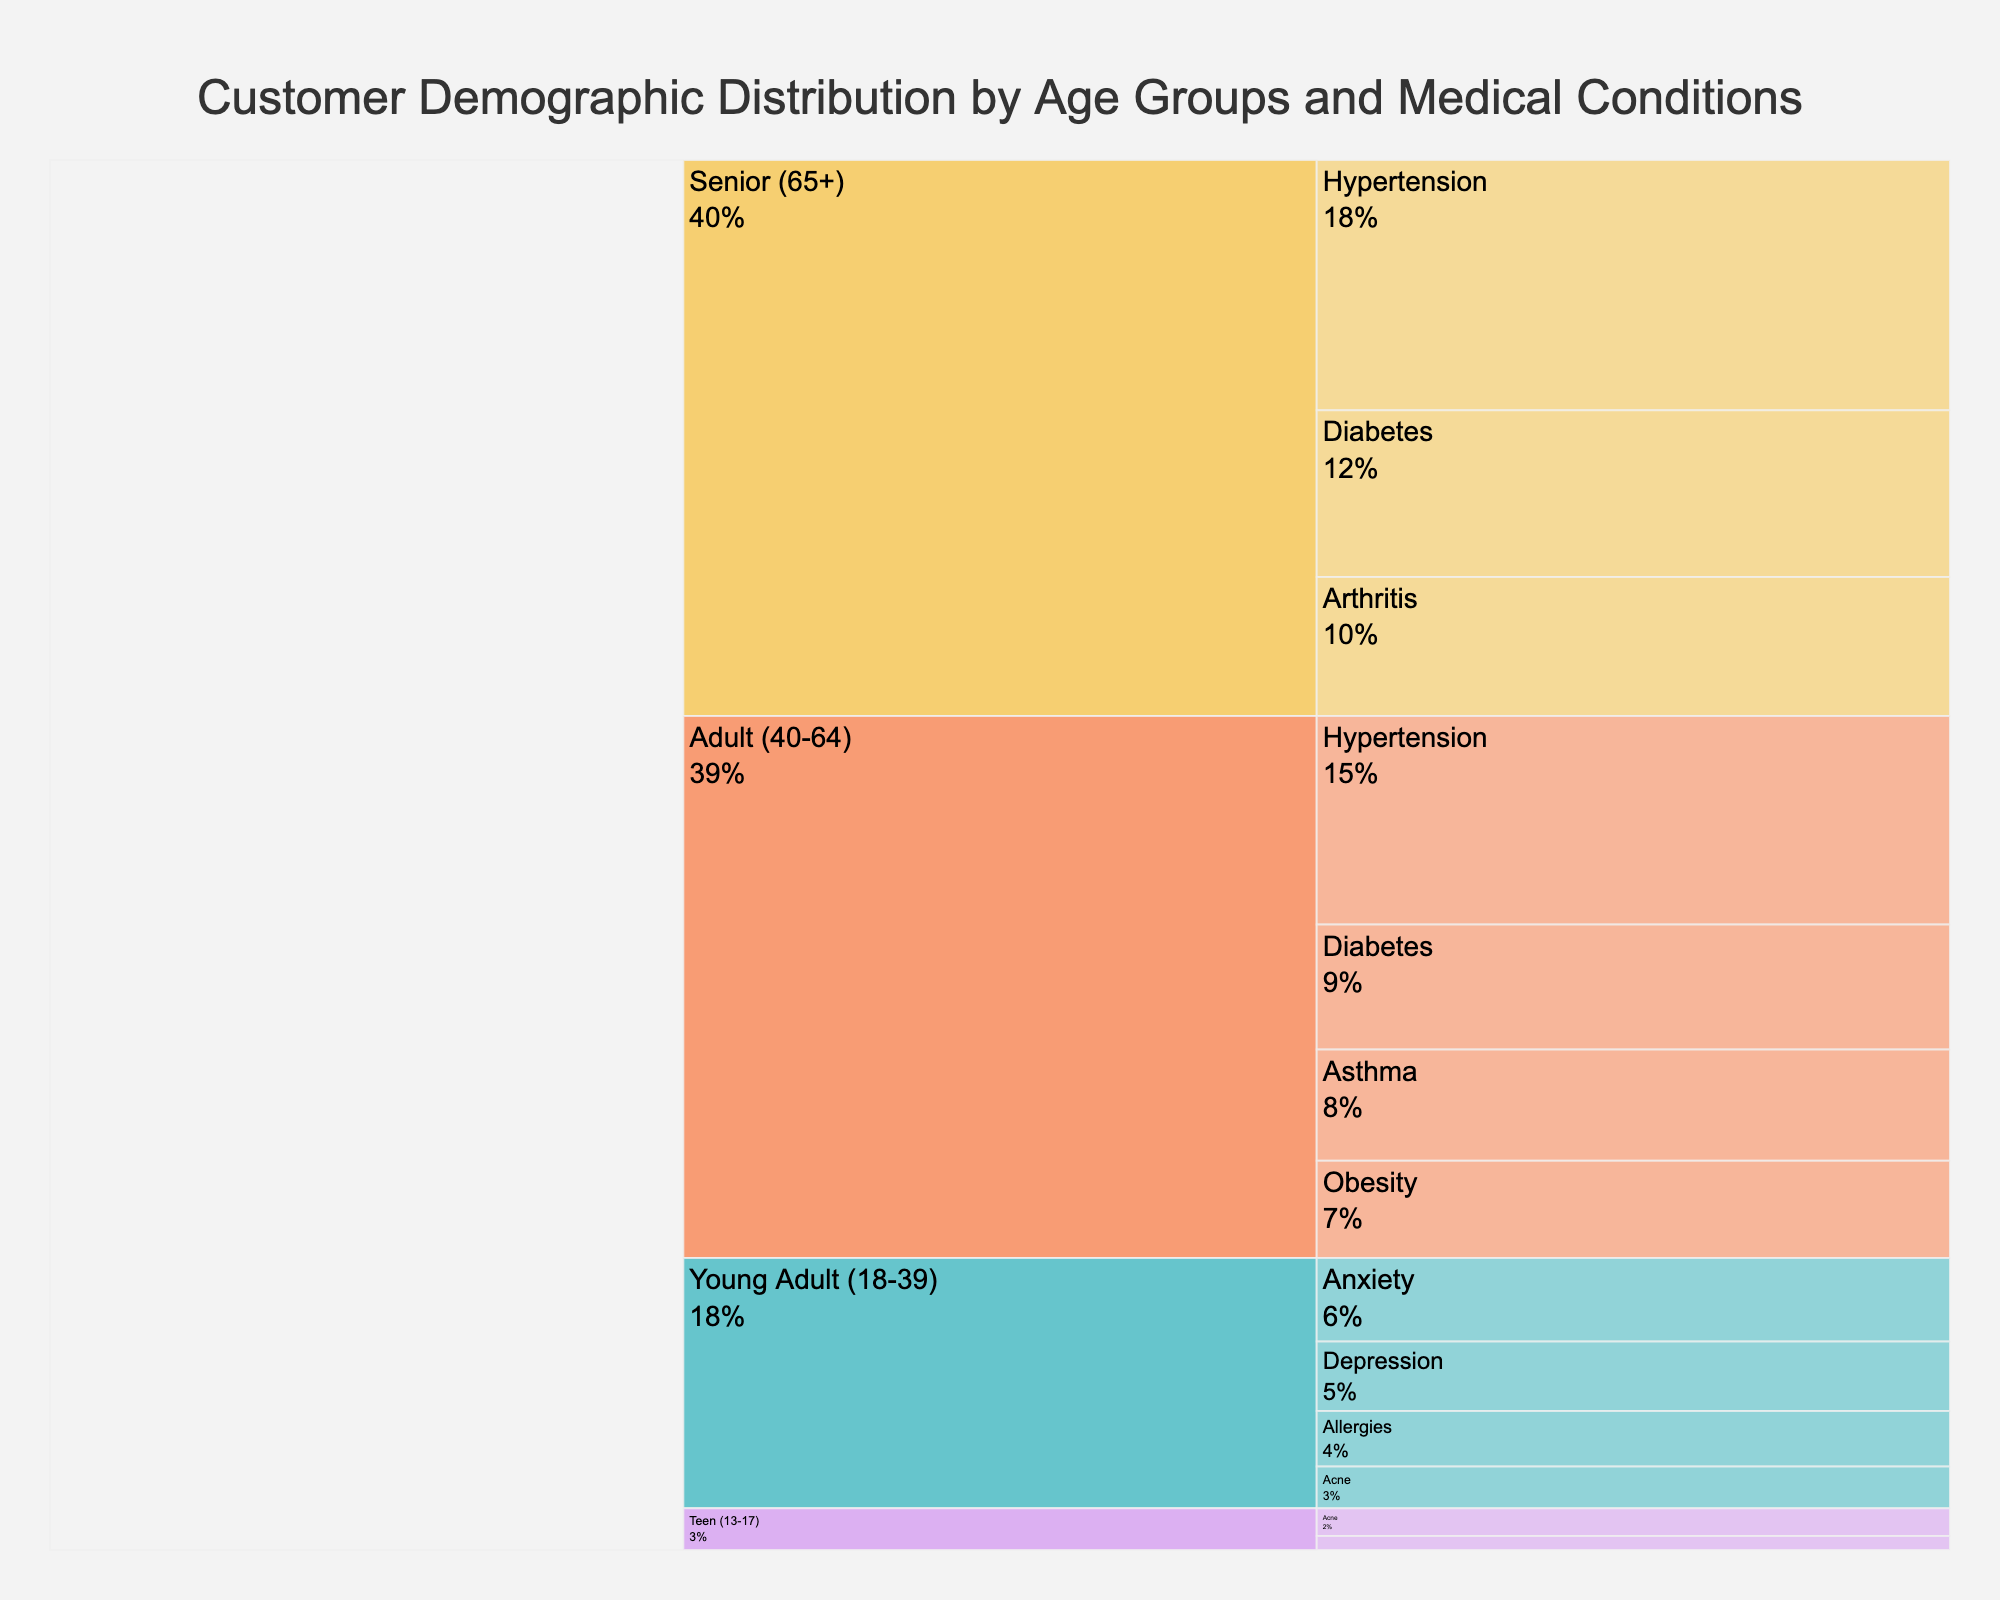what are the main age groups represented in this chart? The chart represents four main age groups: Senior (65+), Adult (40-64), Young Adult (18-39), and Teen (13-17). These categories are visible on the outer branches of the icicle chart.
Answer: Senior (65+), Adult (40-64), Young Adult (18-39), Teen (13-17) which age group has the highest total percentage of medical conditions? By observing the icicle chart, the segments representing different medical conditions are stacked within age groups. The height of the segments visually indicates the total percentage. The Senior (65+) age group has the highest total percentage of medical conditions.
Answer: Senior (65+) what percentage of adults (40-64 years) suffer from hypertension? Look at the Adult (40-64) age group and find its segment for Hypertension within the icicle chart. The percentage value for Hypertension in this age group is labeled as 15%.
Answer: 15% how does the percentage of arthritis in seniors compare to the percentage of obesity in adults? First, find the percentage of Arthritis in the Senior (65+) group, which is 10%. Next, find the percentage of Obesity in the Adult (40-64) group, which is 7%. Compare these two values; 10% is greater than 7%.
Answer: Arthritis in seniors (10%) is greater than Obesity in adults (7%) which medical condition is most common among young adults (18-39 years)? Identify the segments under the Young Adult (18-39) age group. The segments are Anxiety, Depression, Allergies, and Acne. The largest segment, representing the highest percentage, is Anxiety with 6%.
Answer: Anxiety what is the combined percentage of cardiovascular-related conditions (Hypertension and Diabetes) in seniors? Identify the segments for Hypertension and Diabetes within the Senior (65+) group. Hypertension has 18% and Diabetes has 12%. Sum these values: 18% + 12% = 30%.
Answer: 30% in which age group is acne most prevalent? Examine the segments labeled for Acne across different age groups. Acne appears in the Young Adult (18-39) and Teen (13-17) groups. Compare their percentages: 3% in Young Adults and 2% in Teens. Therefore, Young Adults have a higher prevalence.
Answer: Young Adult (18-39) what is the total percentage of medical condition representation for the Teen group? Sum the percentages of Acne and Allergies within the Teen (13-17) group. The values are 2% and 1%. Hence, the total percentage is 2% + 1% = 3%.
Answer: 3% how does the prevalence of diabetes in seniors compare to that in adults? Find the percentage of Diabetes in the Senior (65+) group, which is 12%, and in the Adult (40-64) group, which is 9%. Compare these values; 12% is greater than 9%.
Answer: Diabetes in seniors (12%) is greater than in adults (9%) what percentage of the customer demographic does allergies represent in the Young Adult and Teen groups combined? First, find the percentage of Allergies in the Young Adult (18-39) group, which is 4%, and in the Teen (13-17) group, which is 1%. Sum these values: 4% + 1% = 5%.
Answer: 5% 